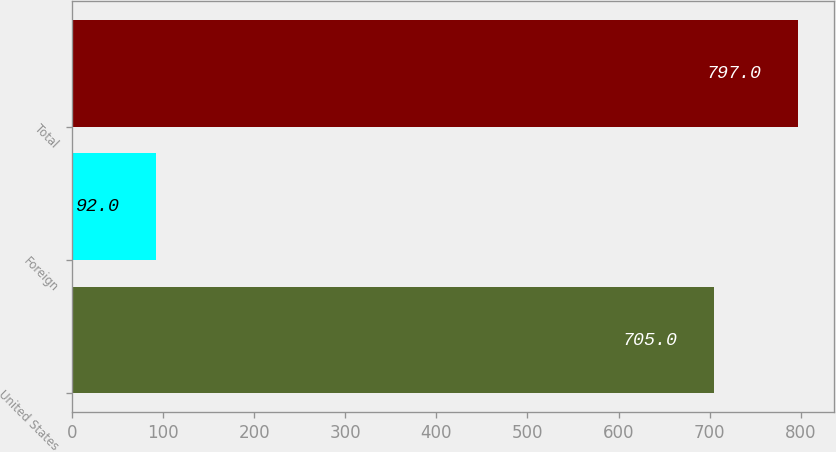Convert chart to OTSL. <chart><loc_0><loc_0><loc_500><loc_500><bar_chart><fcel>United States<fcel>Foreign<fcel>Total<nl><fcel>705<fcel>92<fcel>797<nl></chart> 